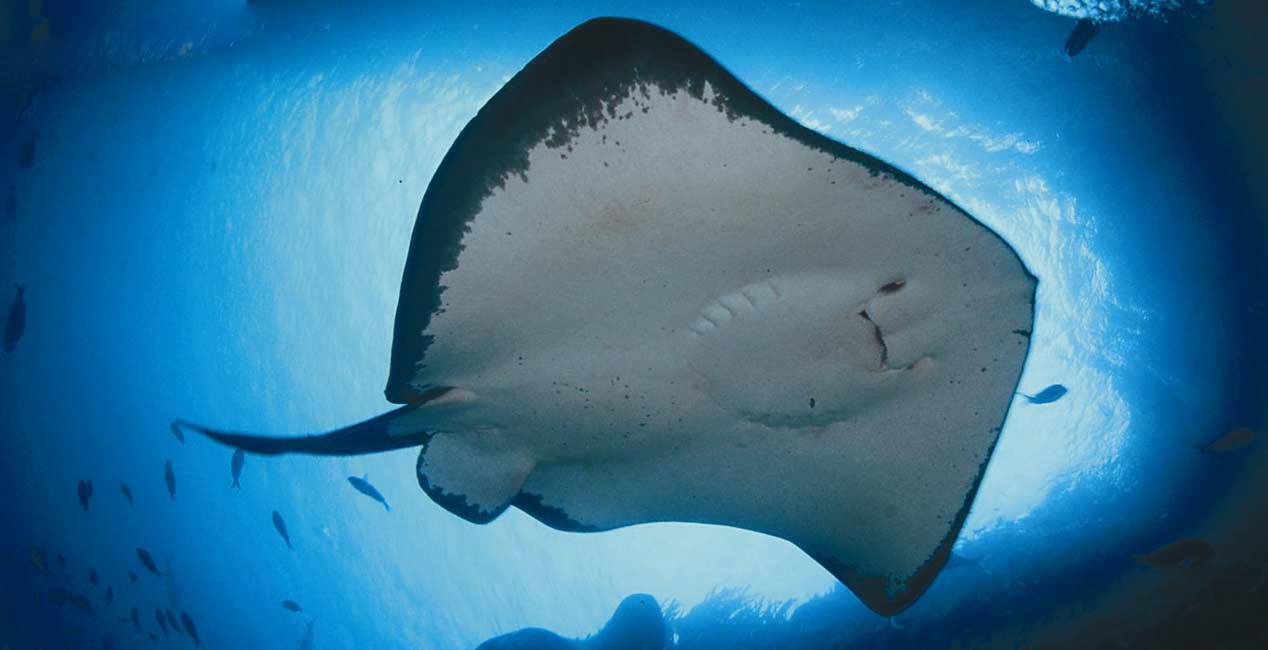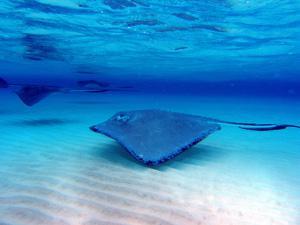The first image is the image on the left, the second image is the image on the right. Examine the images to the left and right. Is the description "the left images shows a stingray swimming with the full under belly showing" accurate? Answer yes or no. Yes. The first image is the image on the left, the second image is the image on the right. Evaluate the accuracy of this statement regarding the images: "In one image there is a ray that is swimming very close to the ocean floor.". Is it true? Answer yes or no. Yes. 